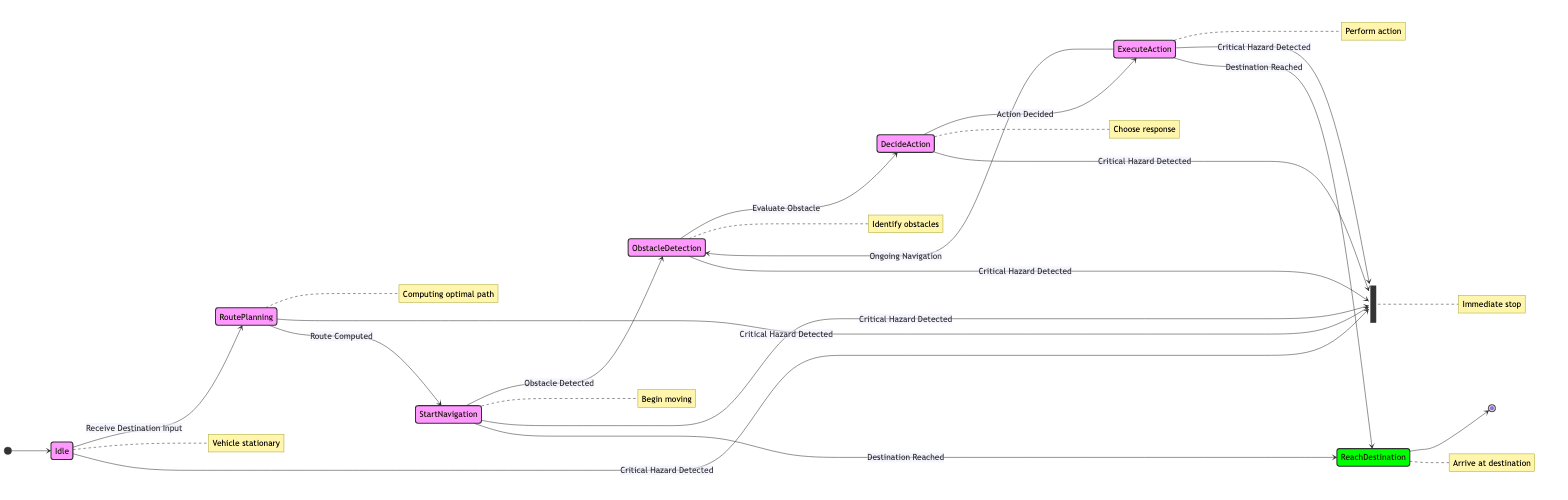What is the starting state of the vehicle? The starting state is represented by the arrow pointing to "Idle". Since the diagram begins with this arrow, we can determine that "Idle" is where the vehicle commences its navigation process.
Answer: Idle How many states are present in the diagram? By counting the states listed in the provided data, we identify there are eight distinct states: Idle, Route Planning, Start Navigation, Obstacle Detection, Decide Action, Execute Action, Reach Destination, and Emergency Stop.
Answer: 8 What transition triggers moving from Route Planning to Start Navigation? According to the data, the transition from "Route Planning" to "Start Navigation" is triggered by the event "Route Computed". This event indicates the planning phase is complete and the vehicle is ready to begin moving towards its destination.
Answer: Route Computed Which state comes after Obstacle Detection? The state that follows "Obstacle Detection" is "Decide Action". This is the next logical step in the decision-making process regarding how to respond to detected obstacles in the vehicle's path.
Answer: Decide Action How many ways can the vehicle reach its destination after starting navigation? The vehicle can reach its destination in two ways: by transitioning directly from "Start Navigation" to "Reach Destination" upon both states recognizing the "Destination Reached" trigger, or by going through the obstacle management steps ("Start Navigation" to "Obstacle Detection" to "Decide Action" to "Execute Action" and then to "Reach Destination"). This gives two distinct paths to reach the destination.
Answer: 2 What state occurs immediately after Execute Action? The state that occurs immediately after "Execute Action" can either loop back to "Obstacle Detection" due to ongoing navigation, or transition to "Reach Destination" if the destination has been successfully reached. The answer focuses on knowing that both choices stem from the "Execute Action" state.
Answer: Obstacle Detection or Reach Destination What is the significance of the Emergency Stop state? The "Emergency Stop" state represents a safety mechanism within the autonomous vehicle's navigation system, as it can be triggered from any other state upon detecting a critical hazard. This emphasizes the vehicle's proactive response to dangers and the priority of safety in operation.
Answer: Immediate stop Which state does not lead to any further state transitions? The state "Reach Destination" serves as the concluding state for the vehicle's navigation, indicating that the vehicle has arrived at its intended destination, therefore it does not have outgoing transitions to other states.
Answer: Reach Destination 